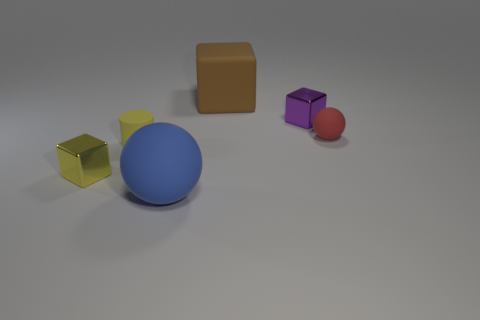How many cyan objects are metallic objects or matte cylinders?
Your response must be concise. 0. What color is the tiny thing that is made of the same material as the yellow cylinder?
Provide a succinct answer. Red. What number of tiny objects are either blue rubber cylinders or yellow objects?
Give a very brief answer. 2. Are there fewer small shiny objects than small blue matte spheres?
Offer a very short reply. No. There is a small thing that is the same shape as the large blue thing; what color is it?
Provide a short and direct response. Red. Is there any other thing that has the same shape as the brown object?
Ensure brevity in your answer.  Yes. Is the number of small red rubber things greater than the number of tiny brown shiny balls?
Keep it short and to the point. Yes. What number of other objects are the same material as the purple cube?
Make the answer very short. 1. What is the shape of the metallic thing that is left of the small metal block to the right of the tiny block in front of the tiny red matte sphere?
Your answer should be compact. Cube. Is the number of small matte cylinders to the right of the red ball less than the number of large brown objects that are right of the small purple object?
Keep it short and to the point. No. 